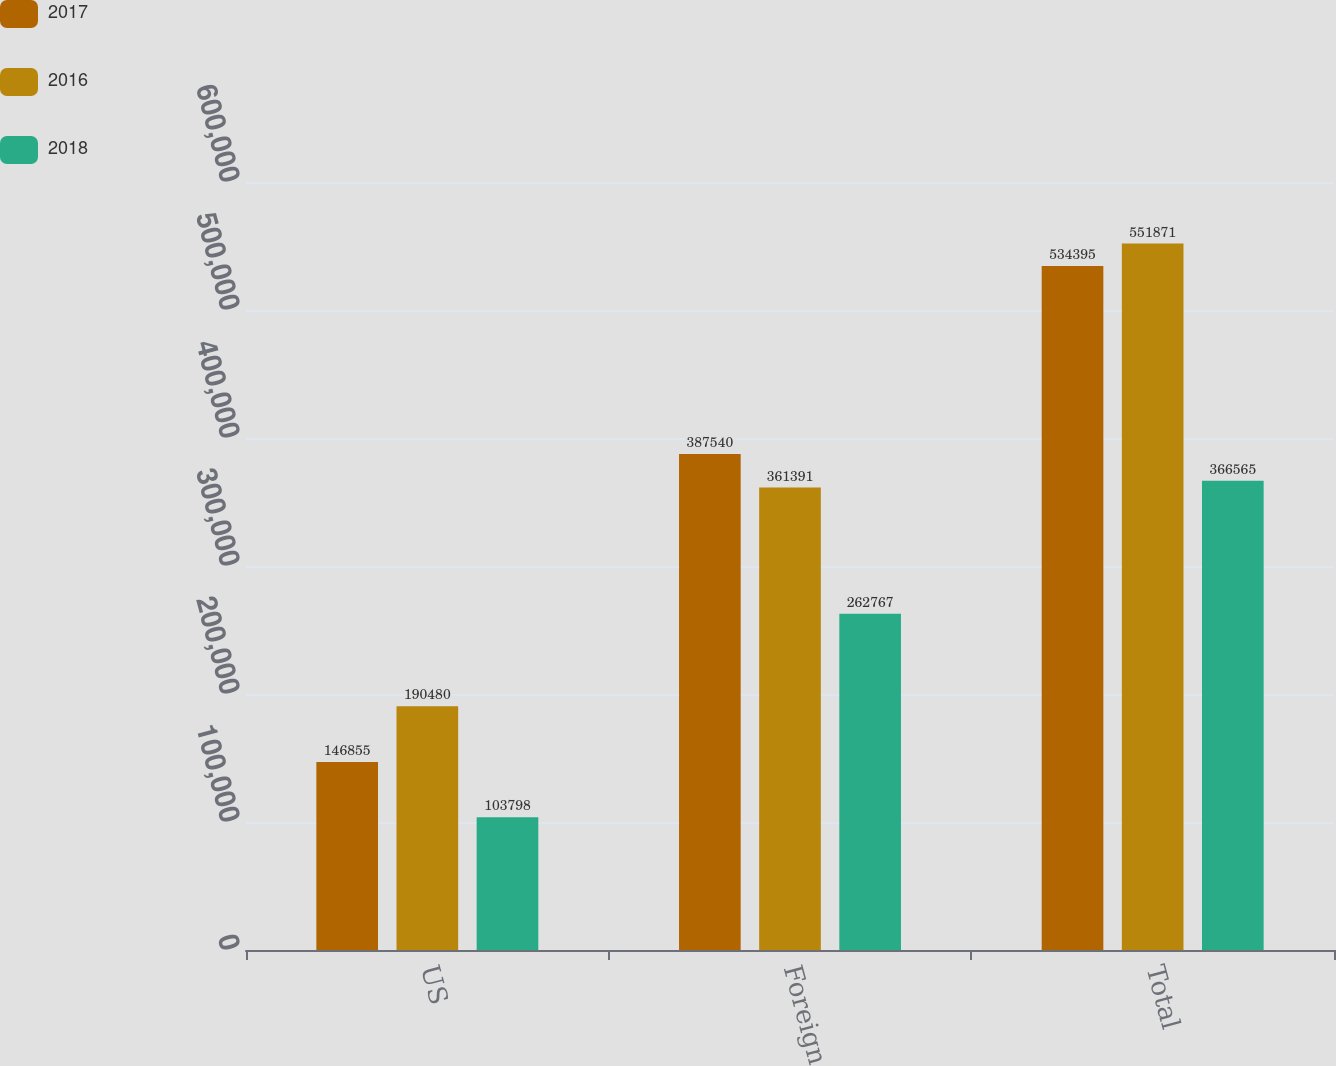<chart> <loc_0><loc_0><loc_500><loc_500><stacked_bar_chart><ecel><fcel>US<fcel>Foreign<fcel>Total<nl><fcel>2017<fcel>146855<fcel>387540<fcel>534395<nl><fcel>2016<fcel>190480<fcel>361391<fcel>551871<nl><fcel>2018<fcel>103798<fcel>262767<fcel>366565<nl></chart> 